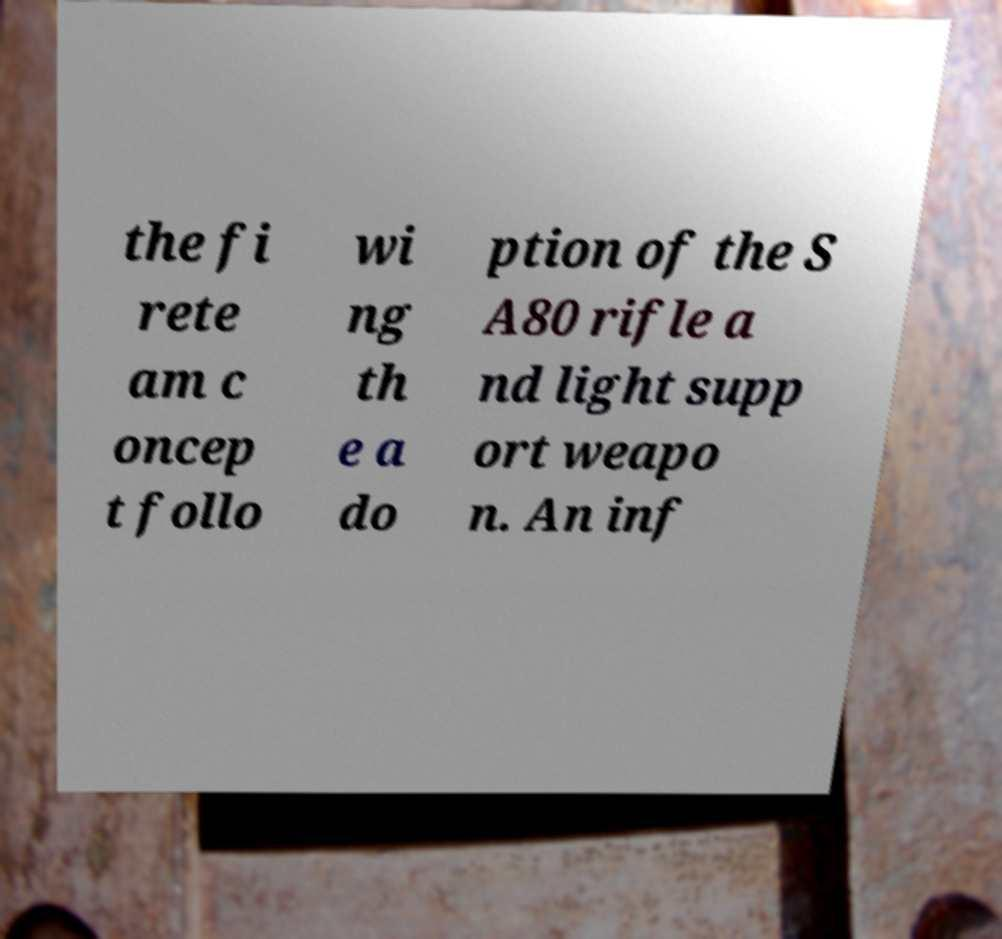I need the written content from this picture converted into text. Can you do that? the fi rete am c oncep t follo wi ng th e a do ption of the S A80 rifle a nd light supp ort weapo n. An inf 